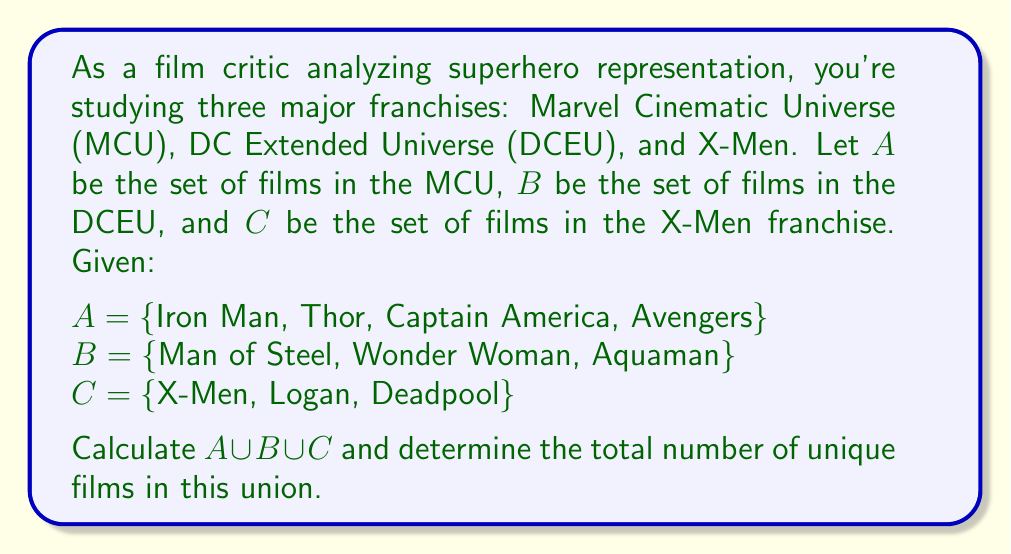Can you answer this question? To solve this problem, we need to understand the concept of union in set theory and apply it to our given sets of superhero films.

1. The union of sets A, B, and C, denoted as $A \cup B \cup C$, is the set of all elements that belong to at least one of these sets.

2. To calculate the union, we list all unique elements from all three sets:

   $A \cup B \cup C = \{$ Iron Man, Thor, Captain America, Avengers, Man of Steel, Wonder Woman, Aquaman, X-Men, Logan, Deadpool $\}$

3. We can see that there are no overlapping elements between the sets, which means each film is unique to its franchise.

4. To determine the total number of unique films in this union, we simply count the elements in the resulting set:

   $|A \cup B \cup C| = 10$

Where $|A \cup B \cup C|$ denotes the cardinality (number of elements) of the union set.
Answer: $A \cup B \cup C = \{$ Iron Man, Thor, Captain America, Avengers, Man of Steel, Wonder Woman, Aquaman, X-Men, Logan, Deadpool $\}$

The total number of unique films in the union is 10. 